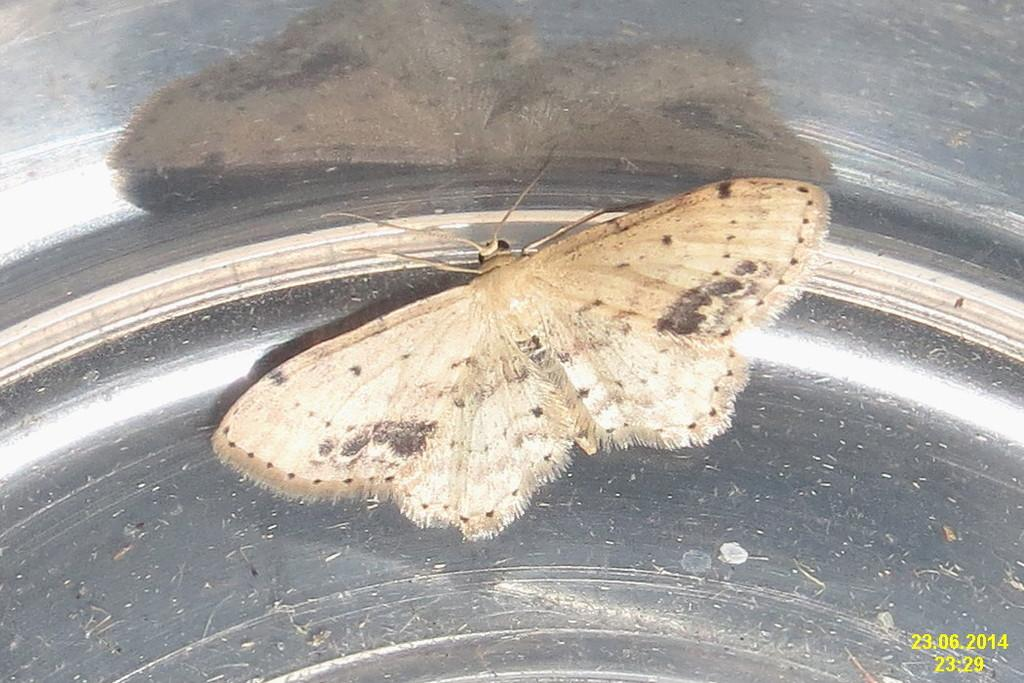What is the main subject of the image? The main subject of the image is a butterfly. Where is the butterfly located in the image? The butterfly is on a surface in the image. What color is the curtain behind the grandfather playing volleyball in the image? There is no grandfather, curtain, or volleyball present in the image; it only features a butterfly on a surface. 